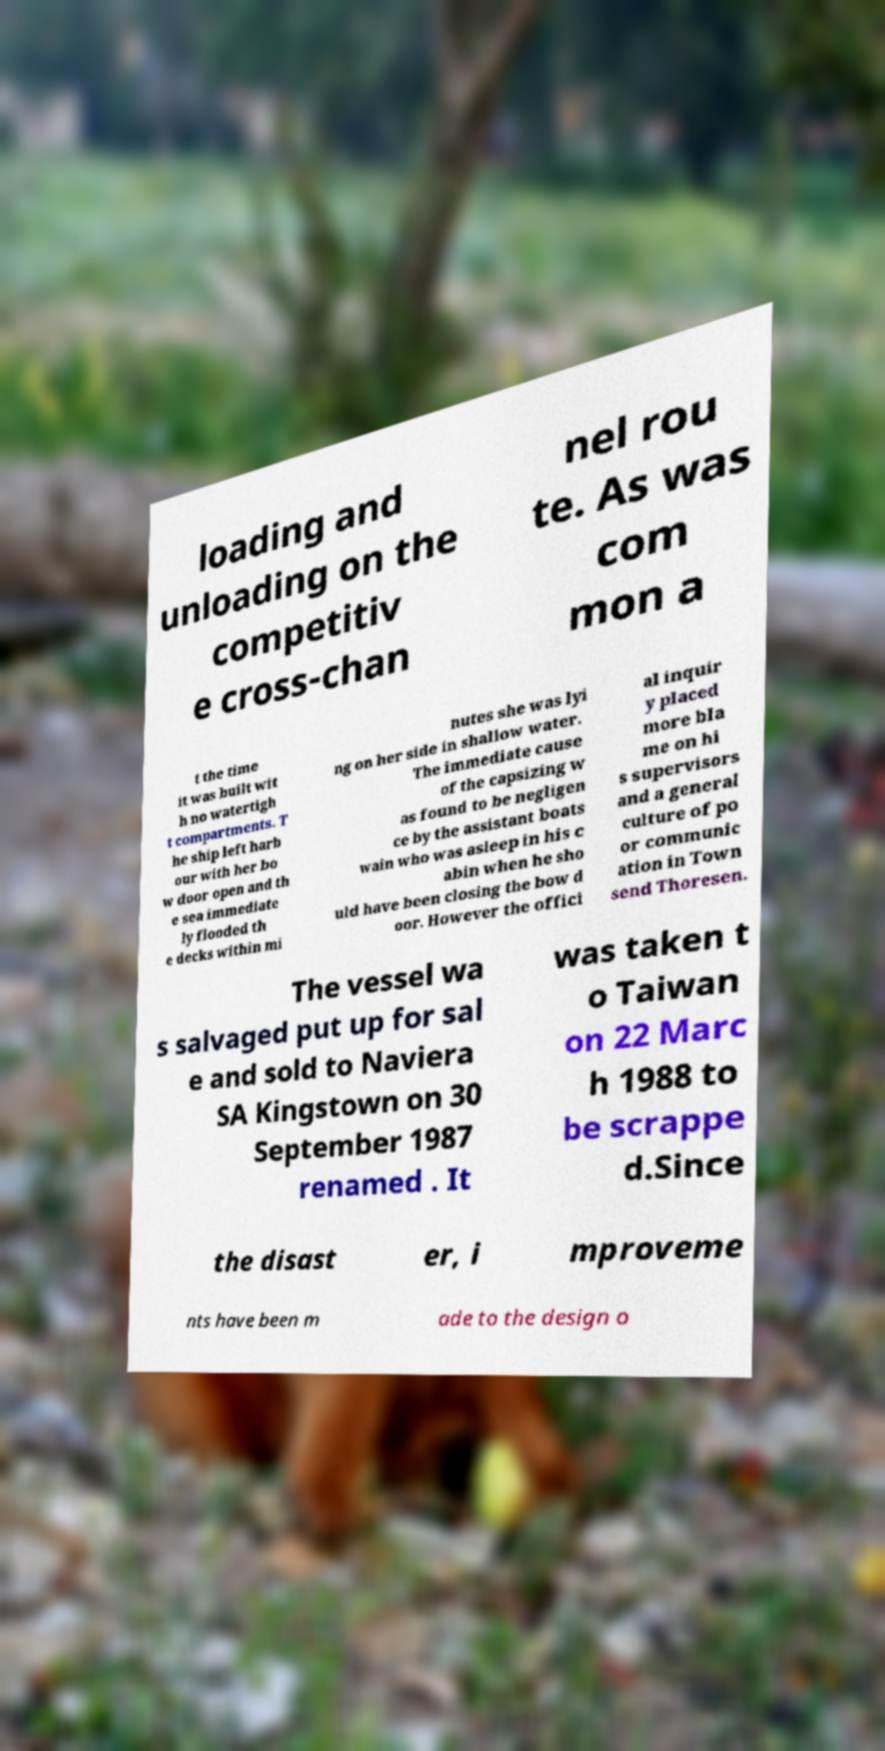Can you read and provide the text displayed in the image?This photo seems to have some interesting text. Can you extract and type it out for me? loading and unloading on the competitiv e cross-chan nel rou te. As was com mon a t the time it was built wit h no watertigh t compartments. T he ship left harb our with her bo w door open and th e sea immediate ly flooded th e decks within mi nutes she was lyi ng on her side in shallow water. The immediate cause of the capsizing w as found to be negligen ce by the assistant boats wain who was asleep in his c abin when he sho uld have been closing the bow d oor. However the offici al inquir y placed more bla me on hi s supervisors and a general culture of po or communic ation in Town send Thoresen. The vessel wa s salvaged put up for sal e and sold to Naviera SA Kingstown on 30 September 1987 renamed . It was taken t o Taiwan on 22 Marc h 1988 to be scrappe d.Since the disast er, i mproveme nts have been m ade to the design o 